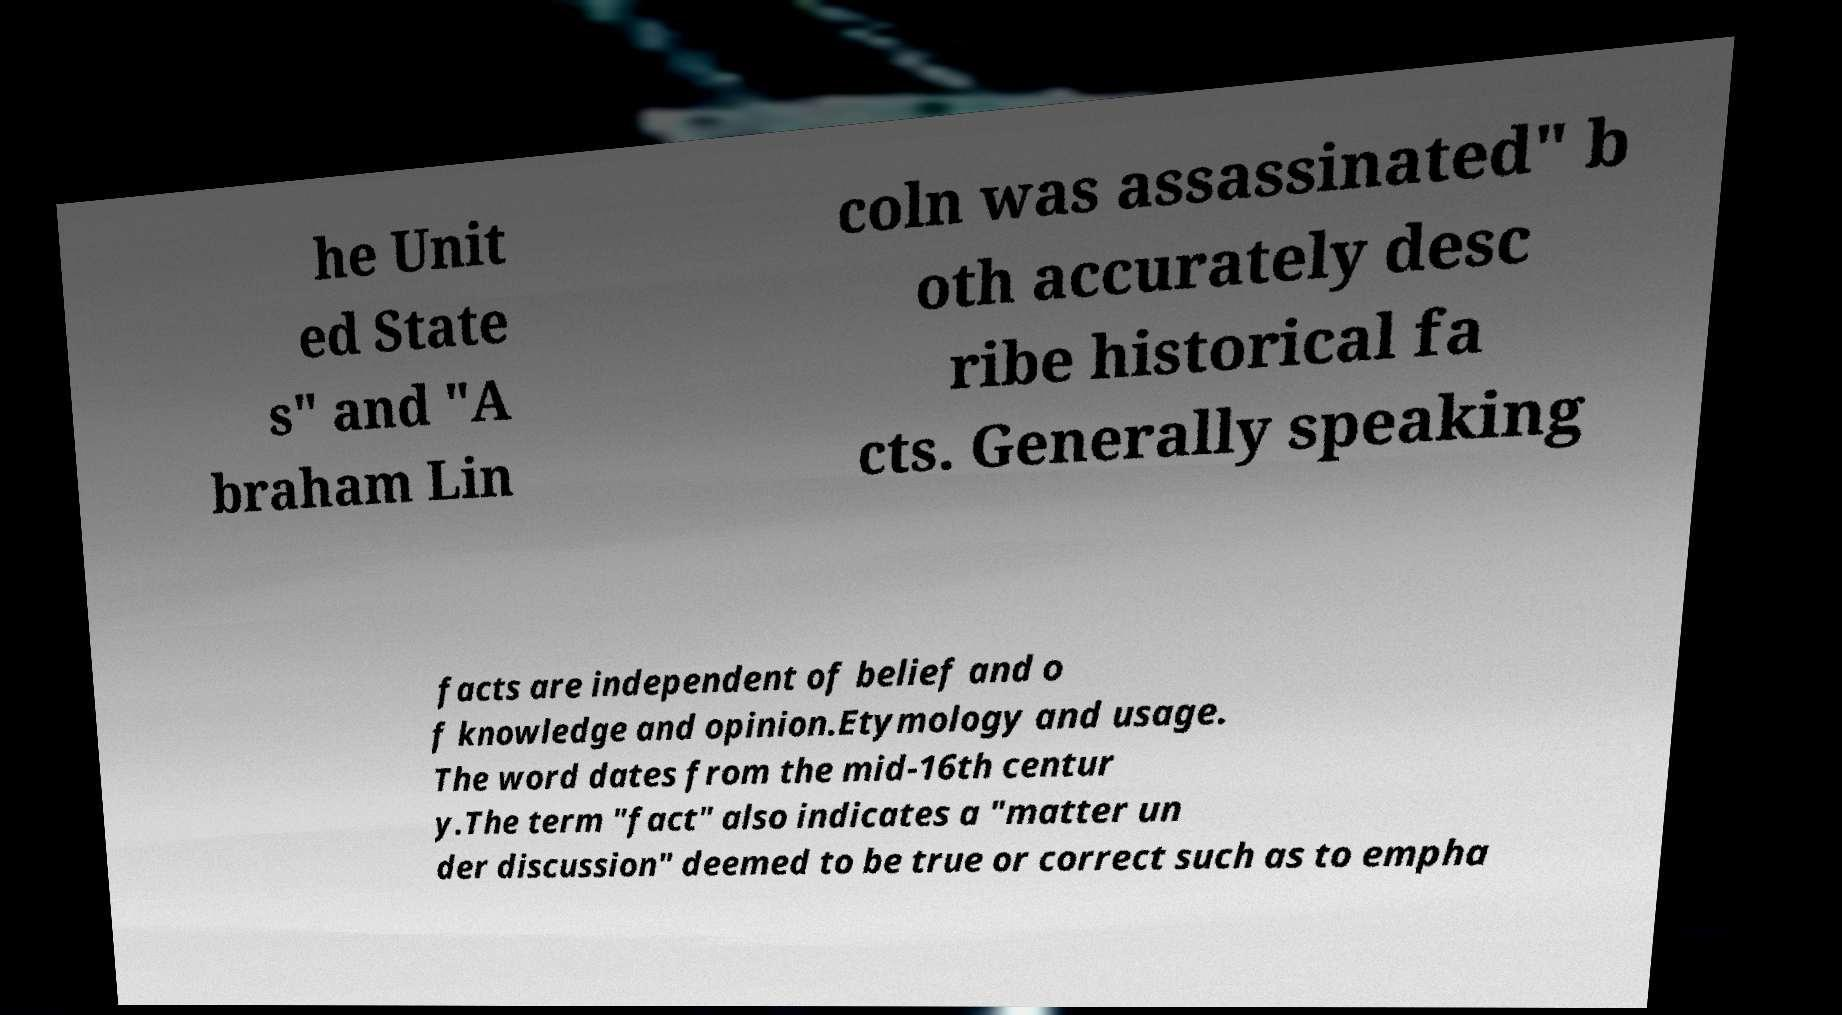There's text embedded in this image that I need extracted. Can you transcribe it verbatim? he Unit ed State s" and "A braham Lin coln was assassinated" b oth accurately desc ribe historical fa cts. Generally speaking facts are independent of belief and o f knowledge and opinion.Etymology and usage. The word dates from the mid-16th centur y.The term "fact" also indicates a "matter un der discussion" deemed to be true or correct such as to empha 